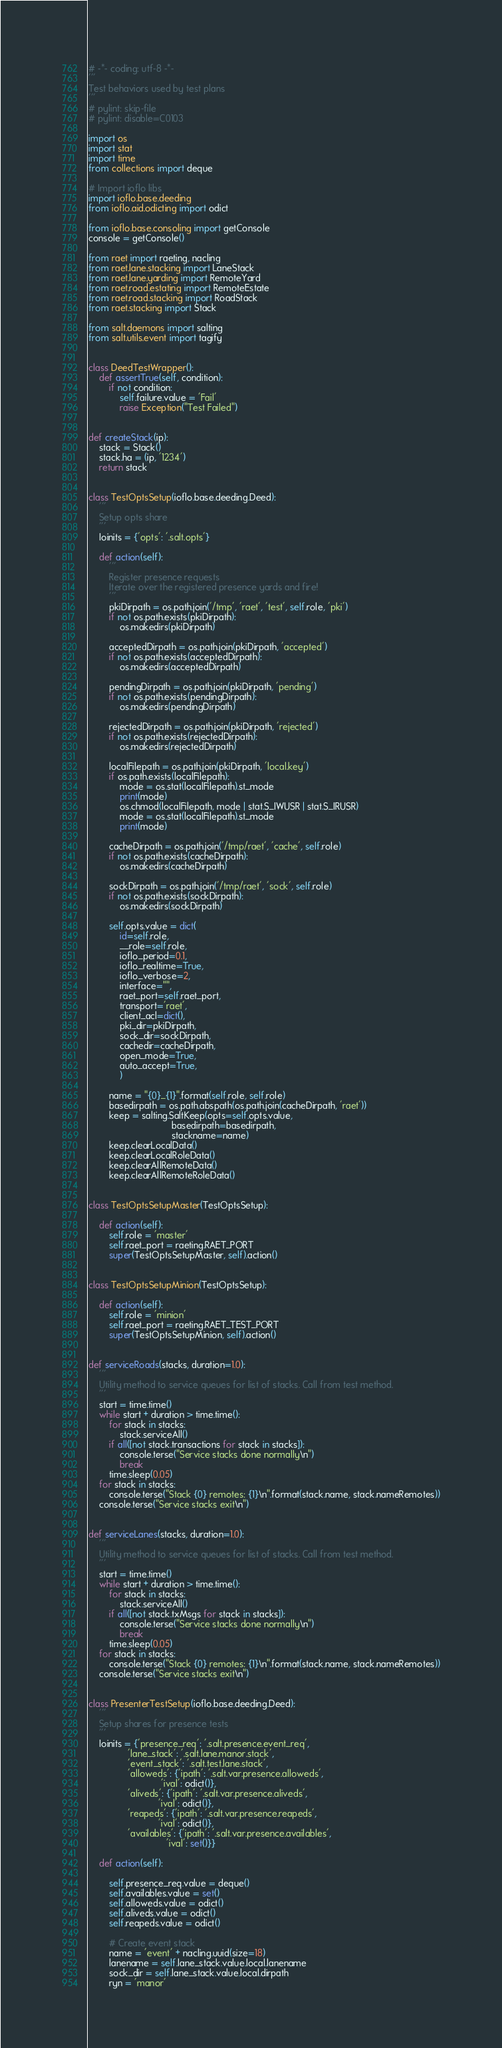<code> <loc_0><loc_0><loc_500><loc_500><_Python_># -*- coding: utf-8 -*-
'''
Test behaviors used by test plans
'''
# pylint: skip-file
# pylint: disable=C0103

import os
import stat
import time
from collections import deque

# Import ioflo libs
import ioflo.base.deeding
from ioflo.aid.odicting import odict

from ioflo.base.consoling import getConsole
console = getConsole()

from raet import raeting, nacling
from raet.lane.stacking import LaneStack
from raet.lane.yarding import RemoteYard
from raet.road.estating import RemoteEstate
from raet.road.stacking import RoadStack
from raet.stacking import Stack

from salt.daemons import salting
from salt.utils.event import tagify


class DeedTestWrapper():
    def assertTrue(self, condition):
        if not condition:
            self.failure.value = 'Fail'
            raise Exception("Test Failed")


def createStack(ip):
    stack = Stack()
    stack.ha = (ip, '1234')
    return stack


class TestOptsSetup(ioflo.base.deeding.Deed):
    '''
    Setup opts share
    '''
    Ioinits = {'opts': '.salt.opts'}

    def action(self):
        '''
        Register presence requests
        Iterate over the registered presence yards and fire!
        '''
        pkiDirpath = os.path.join('/tmp', 'raet', 'test', self.role, 'pki')
        if not os.path.exists(pkiDirpath):
            os.makedirs(pkiDirpath)

        acceptedDirpath = os.path.join(pkiDirpath, 'accepted')
        if not os.path.exists(acceptedDirpath):
            os.makedirs(acceptedDirpath)

        pendingDirpath = os.path.join(pkiDirpath, 'pending')
        if not os.path.exists(pendingDirpath):
            os.makedirs(pendingDirpath)

        rejectedDirpath = os.path.join(pkiDirpath, 'rejected')
        if not os.path.exists(rejectedDirpath):
            os.makedirs(rejectedDirpath)

        localFilepath = os.path.join(pkiDirpath, 'local.key')
        if os.path.exists(localFilepath):
            mode = os.stat(localFilepath).st_mode
            print(mode)
            os.chmod(localFilepath, mode | stat.S_IWUSR | stat.S_IRUSR)
            mode = os.stat(localFilepath).st_mode
            print(mode)

        cacheDirpath = os.path.join('/tmp/raet', 'cache', self.role)
        if not os.path.exists(cacheDirpath):
            os.makedirs(cacheDirpath)

        sockDirpath = os.path.join('/tmp/raet', 'sock', self.role)
        if not os.path.exists(sockDirpath):
            os.makedirs(sockDirpath)

        self.opts.value = dict(
            id=self.role,
            __role=self.role,
            ioflo_period=0.1,
            ioflo_realtime=True,
            ioflo_verbose=2,
            interface="",
            raet_port=self.raet_port,
            transport='raet',
            client_acl=dict(),
            pki_dir=pkiDirpath,
            sock_dir=sockDirpath,
            cachedir=cacheDirpath,
            open_mode=True,
            auto_accept=True,
            )

        name = "{0}_{1}".format(self.role, self.role)
        basedirpath = os.path.abspath(os.path.join(cacheDirpath, 'raet'))
        keep = salting.SaltKeep(opts=self.opts.value,
                                basedirpath=basedirpath,
                                stackname=name)
        keep.clearLocalData()
        keep.clearLocalRoleData()
        keep.clearAllRemoteData()
        keep.clearAllRemoteRoleData()


class TestOptsSetupMaster(TestOptsSetup):

    def action(self):
        self.role = 'master'
        self.raet_port = raeting.RAET_PORT
        super(TestOptsSetupMaster, self).action()


class TestOptsSetupMinion(TestOptsSetup):

    def action(self):
        self.role = 'minion'
        self.raet_port = raeting.RAET_TEST_PORT
        super(TestOptsSetupMinion, self).action()


def serviceRoads(stacks, duration=1.0):
    '''
    Utility method to service queues for list of stacks. Call from test method.
    '''
    start = time.time()
    while start + duration > time.time():
        for stack in stacks:
            stack.serviceAll()
        if all([not stack.transactions for stack in stacks]):
            console.terse("Service stacks done normally\n")
            break
        time.sleep(0.05)
    for stack in stacks:
        console.terse("Stack {0} remotes: {1}\n".format(stack.name, stack.nameRemotes))
    console.terse("Service stacks exit\n")


def serviceLanes(stacks, duration=1.0):
    '''
    Utility method to service queues for list of stacks. Call from test method.
    '''
    start = time.time()
    while start + duration > time.time():
        for stack in stacks:
            stack.serviceAll()
        if all([not stack.txMsgs for stack in stacks]):
            console.terse("Service stacks done normally\n")
            break
        time.sleep(0.05)
    for stack in stacks:
        console.terse("Stack {0} remotes: {1}\n".format(stack.name, stack.nameRemotes))
    console.terse("Service stacks exit\n")


class PresenterTestSetup(ioflo.base.deeding.Deed):
    '''
    Setup shares for presence tests
    '''
    Ioinits = {'presence_req': '.salt.presence.event_req',
               'lane_stack': '.salt.lane.manor.stack',
               'event_stack': '.salt.test.lane.stack',
               'alloweds': {'ipath': '.salt.var.presence.alloweds',
                            'ival': odict()},
               'aliveds': {'ipath': '.salt.var.presence.aliveds',
                           'ival': odict()},
               'reapeds': {'ipath': '.salt.var.presence.reapeds',
                           'ival': odict()},
               'availables': {'ipath': '.salt.var.presence.availables',
                              'ival': set()}}

    def action(self):

        self.presence_req.value = deque()
        self.availables.value = set()
        self.alloweds.value = odict()
        self.aliveds.value = odict()
        self.reapeds.value = odict()

        # Create event stack
        name = 'event' + nacling.uuid(size=18)
        lanename = self.lane_stack.value.local.lanename
        sock_dir = self.lane_stack.value.local.dirpath
        ryn = 'manor'</code> 